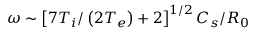<formula> <loc_0><loc_0><loc_500><loc_500>\omega \sim \left [ 7 T _ { i } / \left ( 2 T _ { e } \right ) + 2 \right ] ^ { 1 / 2 } C _ { s } / R _ { 0 }</formula> 